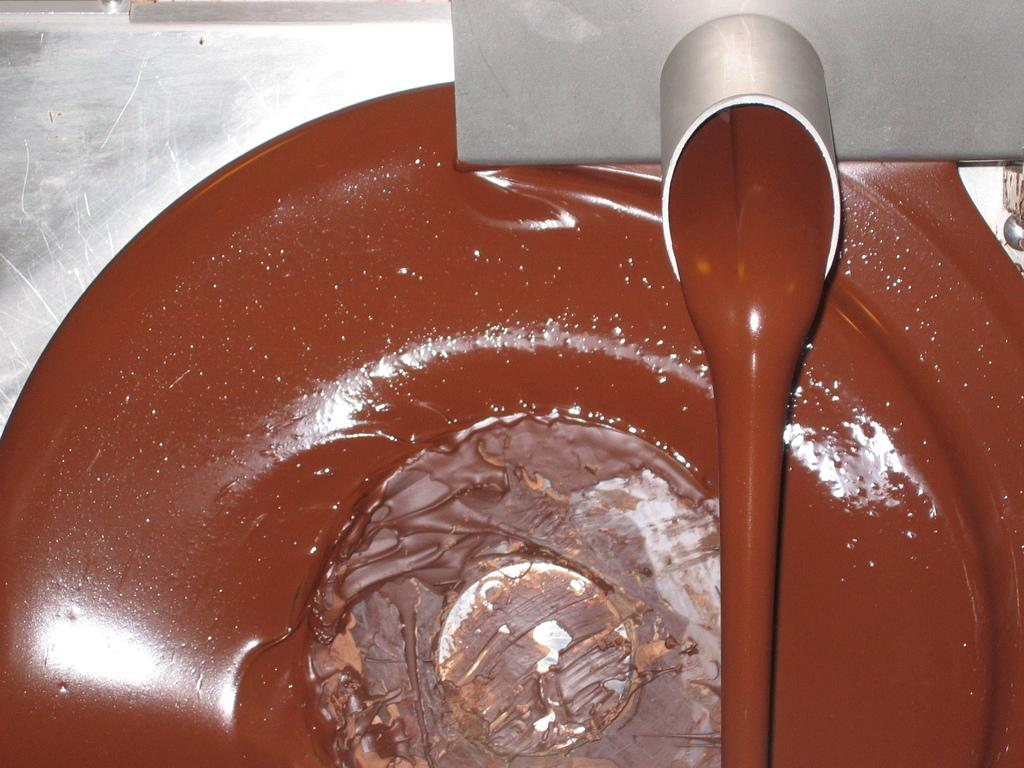What type of machine is present in the image? There is a chocolate machine in the image. What can be seen coming out of the machine? Melted chocolate is visible in the image. What type of jam is being used to write a fictional story on the chocolate in the image? There is no jam or fictional story present in the image; it only features a chocolate machine and melted chocolate. 